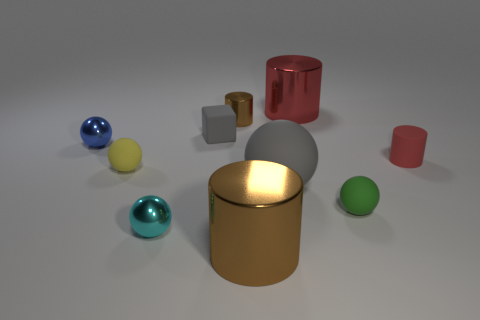What is the material of the block that is the same color as the big rubber object?
Your answer should be very brief. Rubber. How many small red things are there?
Your answer should be compact. 1. Does the small matte cylinder have the same color as the rubber cube?
Your answer should be very brief. No. Is the number of tiny balls that are in front of the large gray rubber sphere less than the number of brown things on the left side of the big brown object?
Offer a terse response. No. The rubber cylinder has what color?
Make the answer very short. Red. How many other objects have the same color as the big matte object?
Your response must be concise. 1. There is a big brown metal cylinder; are there any red cylinders right of it?
Offer a terse response. Yes. Are there an equal number of yellow spheres on the right side of the green rubber sphere and brown cylinders that are behind the large brown shiny cylinder?
Offer a terse response. No. Does the matte sphere that is in front of the gray matte ball have the same size as the cylinder that is to the right of the red shiny thing?
Offer a terse response. Yes. The brown thing that is behind the big metallic cylinder that is in front of the small metallic thing in front of the tiny rubber cylinder is what shape?
Provide a short and direct response. Cylinder. 